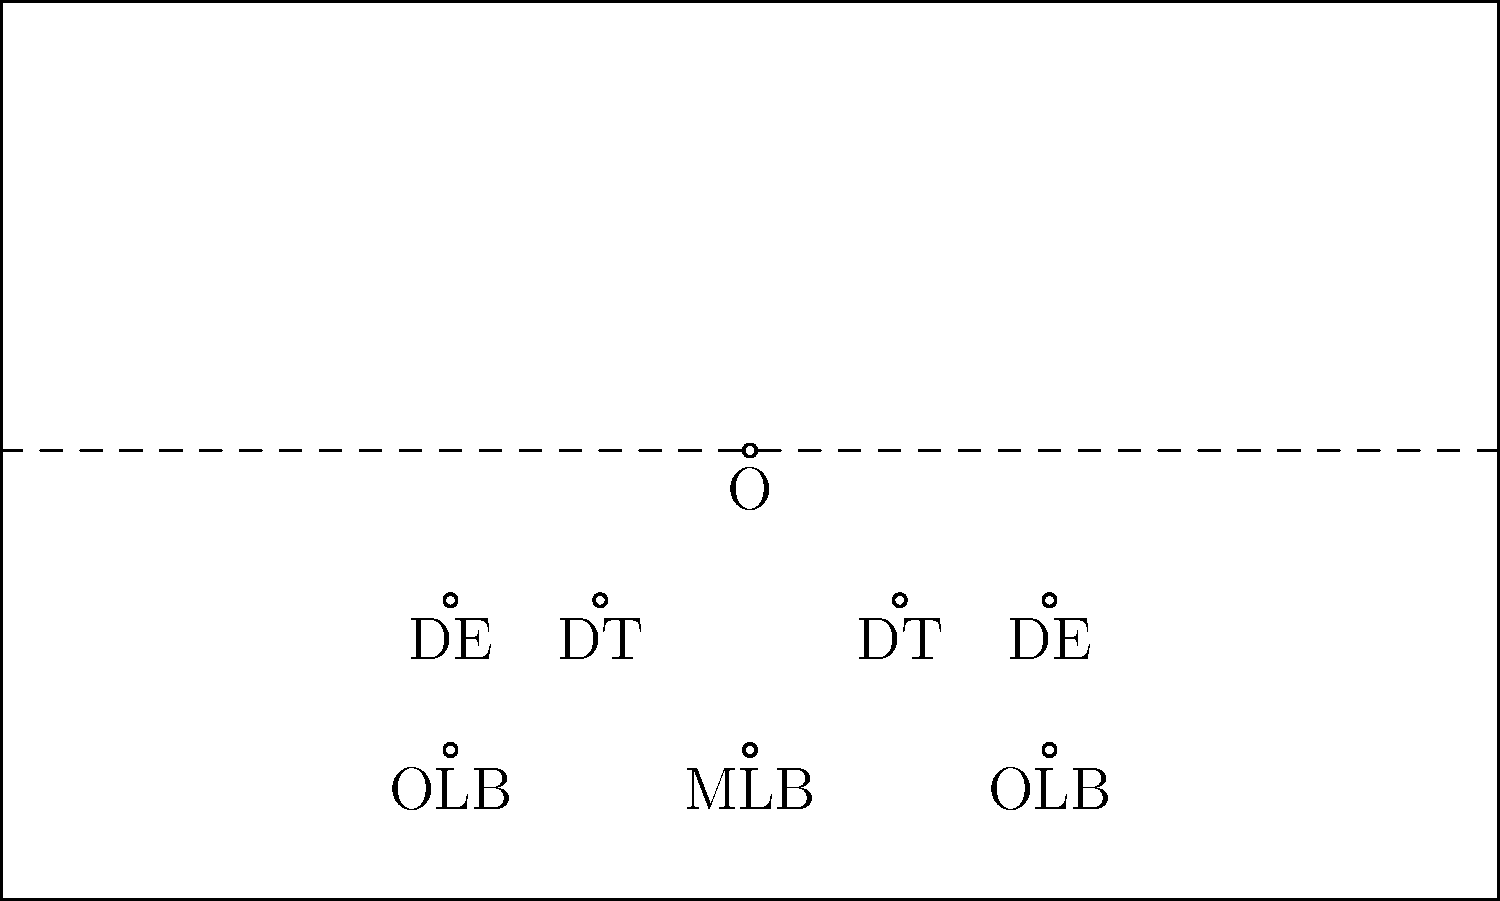In the defensive formation shown, what type of front is being deployed, and how many linebackers are positioned behind the defensive line? To answer this question, let's analyze the defensive formation step-by-step:

1. Defensive Line:
   - There are four players on the line of scrimmage
   - From left to right: DE (Defensive End), DT (Defensive Tackle), DT, DE
   - This arrangement of four down linemen is known as a 4-man front

2. Linebackers:
   - Behind the defensive line, we can see three players
   - In the middle: MLB (Middle Linebacker)
   - On either side: OLB (Outside Linebacker)
   - This is a standard 3-linebacker set

3. Front classification:
   - The combination of 4 down linemen and 3 linebackers is commonly referred to as a 4-3 front
   - This is a balanced formation that provides good run support and pass rush capabilities

Therefore, the defensive front being deployed is a 4-3 front, with 3 linebackers positioned behind the defensive line.
Answer: 4-3 front, 3 linebackers 